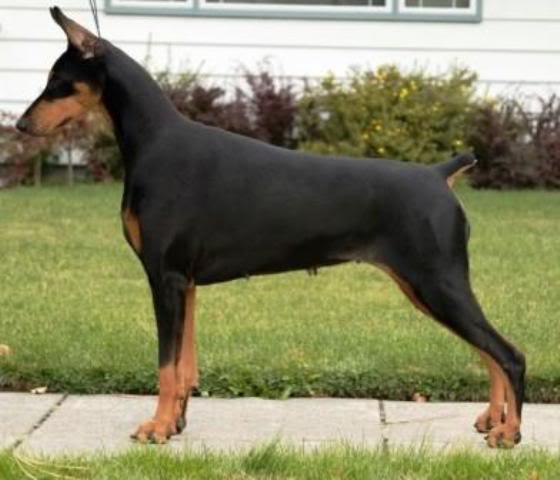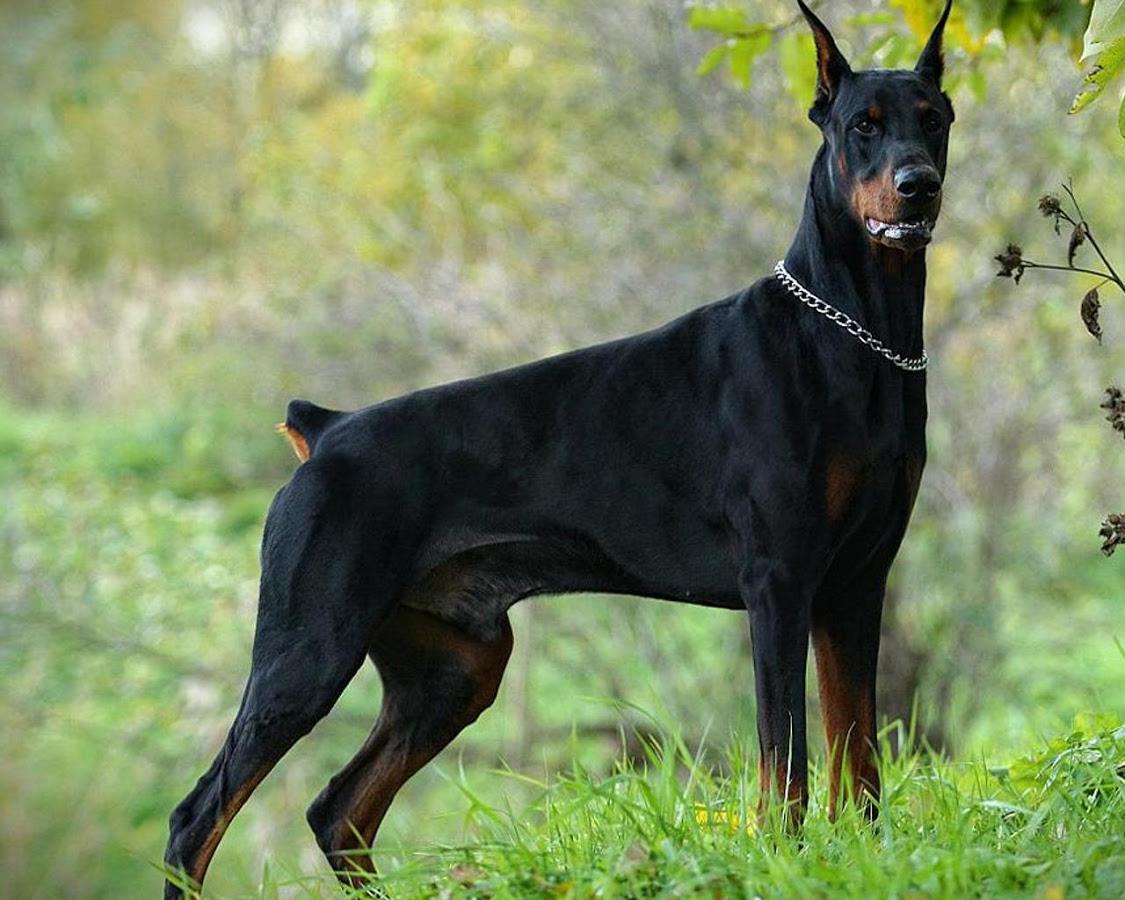The first image is the image on the left, the second image is the image on the right. Examine the images to the left and right. Is the description "Two dobermans can be seen standing at attention while outside." accurate? Answer yes or no. Yes. The first image is the image on the left, the second image is the image on the right. Evaluate the accuracy of this statement regarding the images: "The left image contains one dog facing towards the left.". Is it true? Answer yes or no. Yes. 